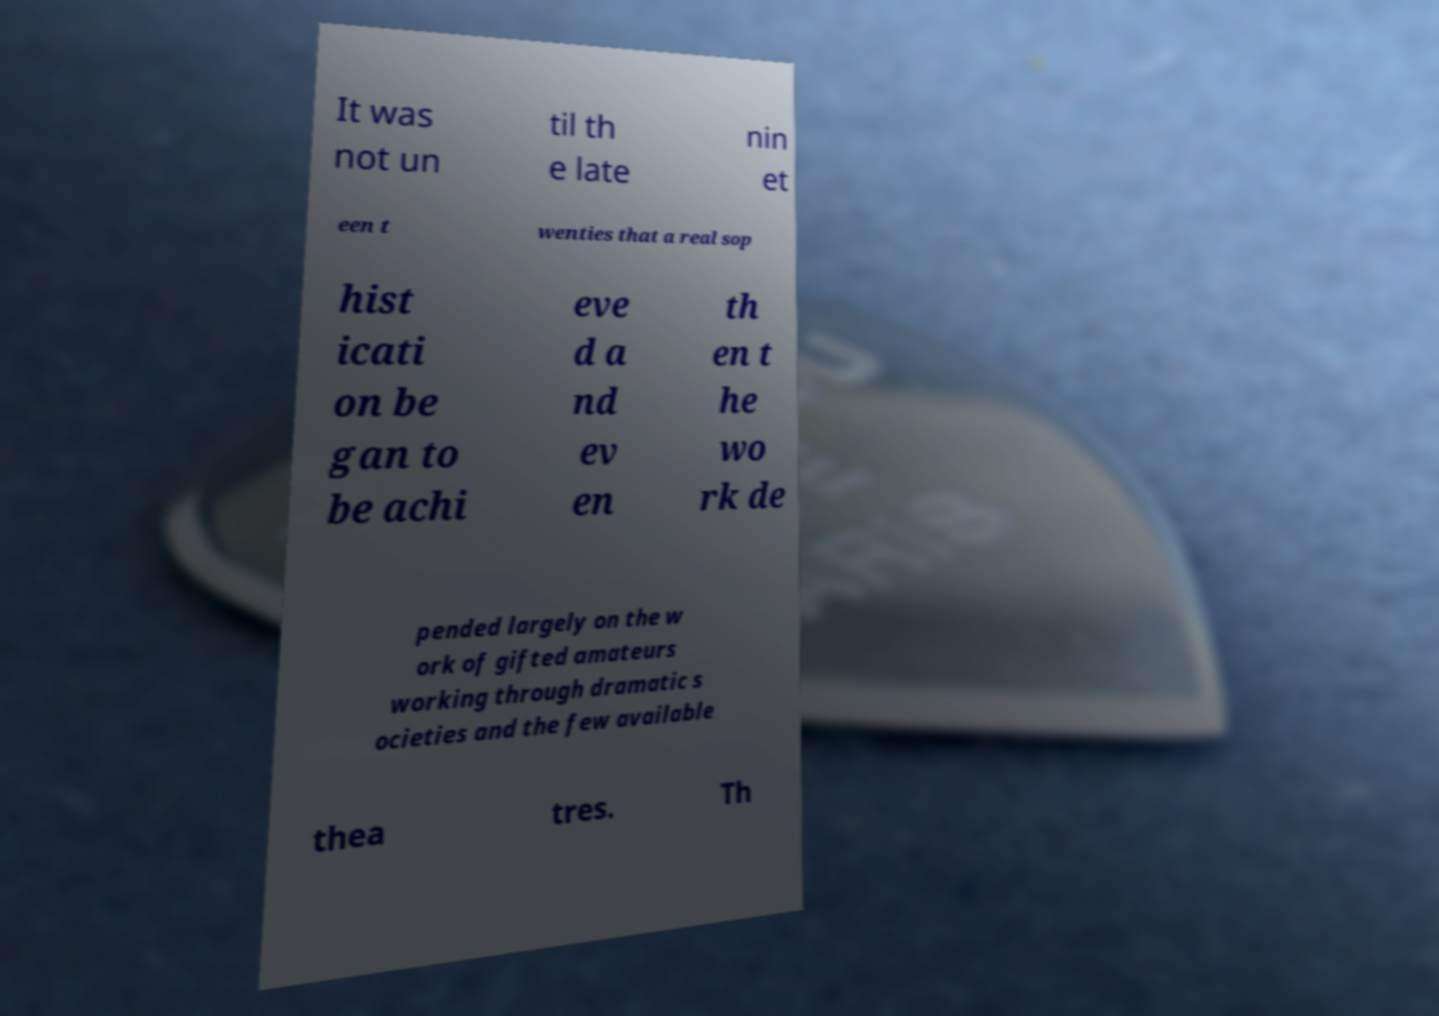Please read and relay the text visible in this image. What does it say? It was not un til th e late nin et een t wenties that a real sop hist icati on be gan to be achi eve d a nd ev en th en t he wo rk de pended largely on the w ork of gifted amateurs working through dramatic s ocieties and the few available thea tres. Th 